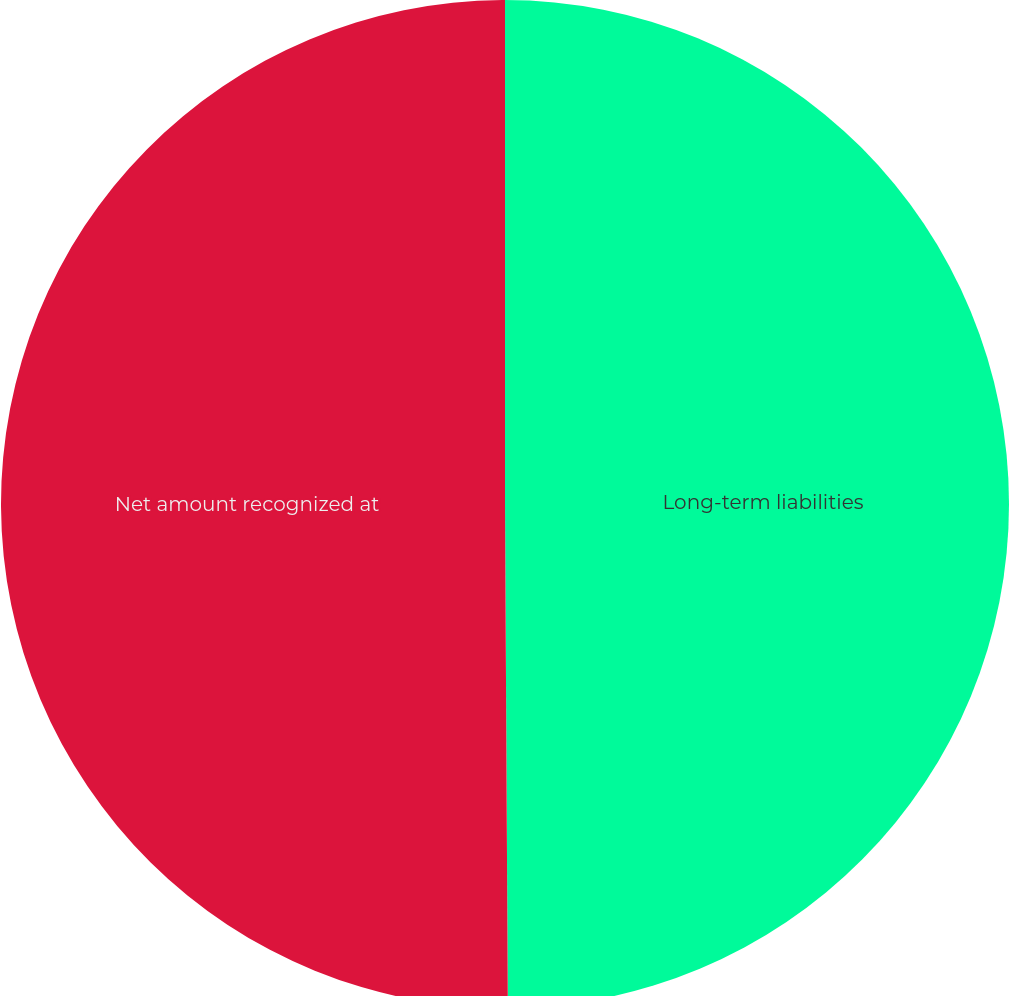Convert chart to OTSL. <chart><loc_0><loc_0><loc_500><loc_500><pie_chart><fcel>Long-term liabilities<fcel>Net amount recognized at<nl><fcel>49.91%<fcel>50.09%<nl></chart> 